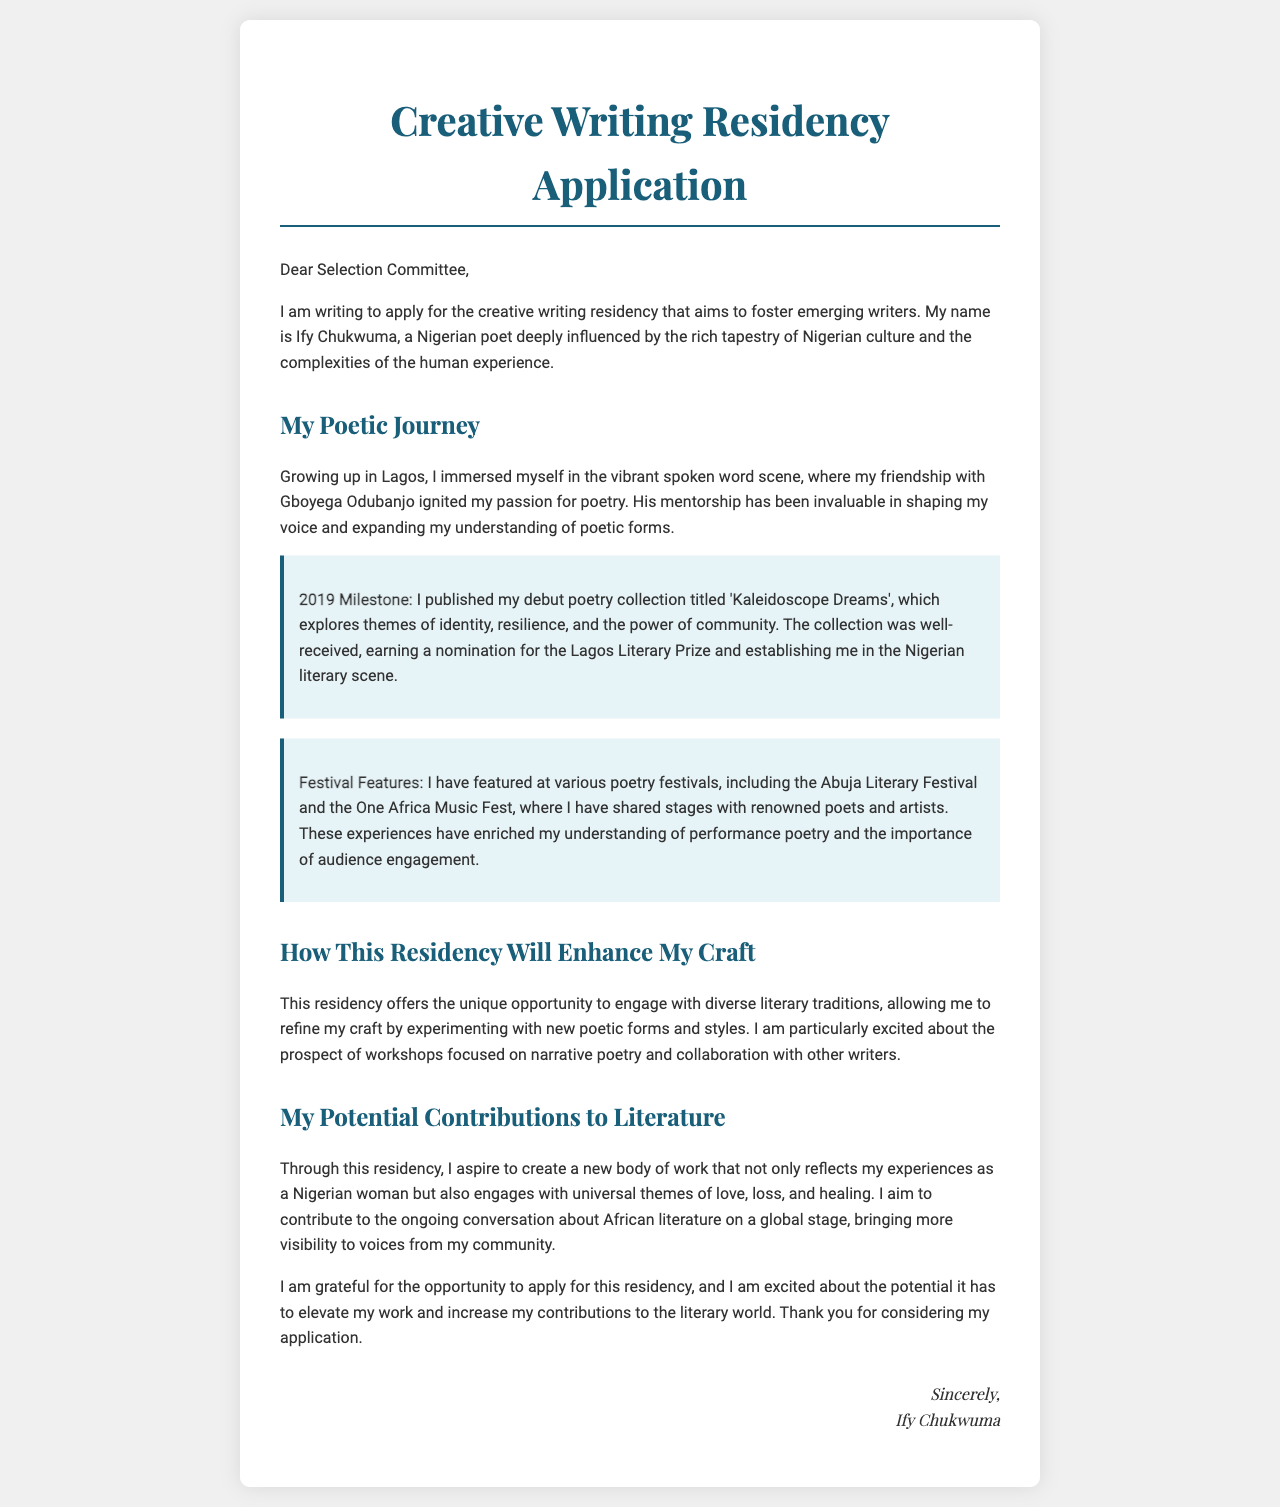What is the name of the applicant? The applicant's name is mentioned at the beginning of the letter.
Answer: Ify Chukwuma What year was the debut poetry collection published? The milestone section specifies the year of publication for the debut collection.
Answer: 2019 What is the title of the debut poetry collection? The title of the poetry collection is stated in the document under the 2019 milestone.
Answer: Kaleidoscope Dreams Which festival did the applicant feature at? The applicant lists various poetry festivals where she has performed.
Answer: Abuja Literary Festival What themes are explored in 'Kaleidoscope Dreams'? The document describes the themes of the debut collection in detail.
Answer: Identity, resilience, and the power of community How will the residency enhance the applicant's craft? The applicant discusses the benefits of the residency and what it offers to her writing.
Answer: Engage with diverse literary traditions What is the main aspiration of the applicant during the residency? The document mentions what the applicant aims to accomplish through the residency.
Answer: Create a new body of work Who has been an influence on the applicant's poetry? The letter indicates a friendship that has shaped her poetic voice.
Answer: Gboyega Odubanjo What type of poetry is the applicant excited to work on during the residency? The document specifies the kind of workshops the applicant is interested in.
Answer: Narrative poetry 